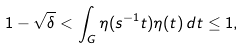<formula> <loc_0><loc_0><loc_500><loc_500>1 - \sqrt { \delta } < \int _ { G } \eta ( s ^ { - 1 } t ) \eta ( t ) \, d t \leq 1 ,</formula> 